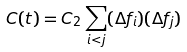Convert formula to latex. <formula><loc_0><loc_0><loc_500><loc_500>C ( t ) = C _ { 2 } \sum _ { i < j } ( \Delta f _ { i } ) ( \Delta f _ { j } )</formula> 